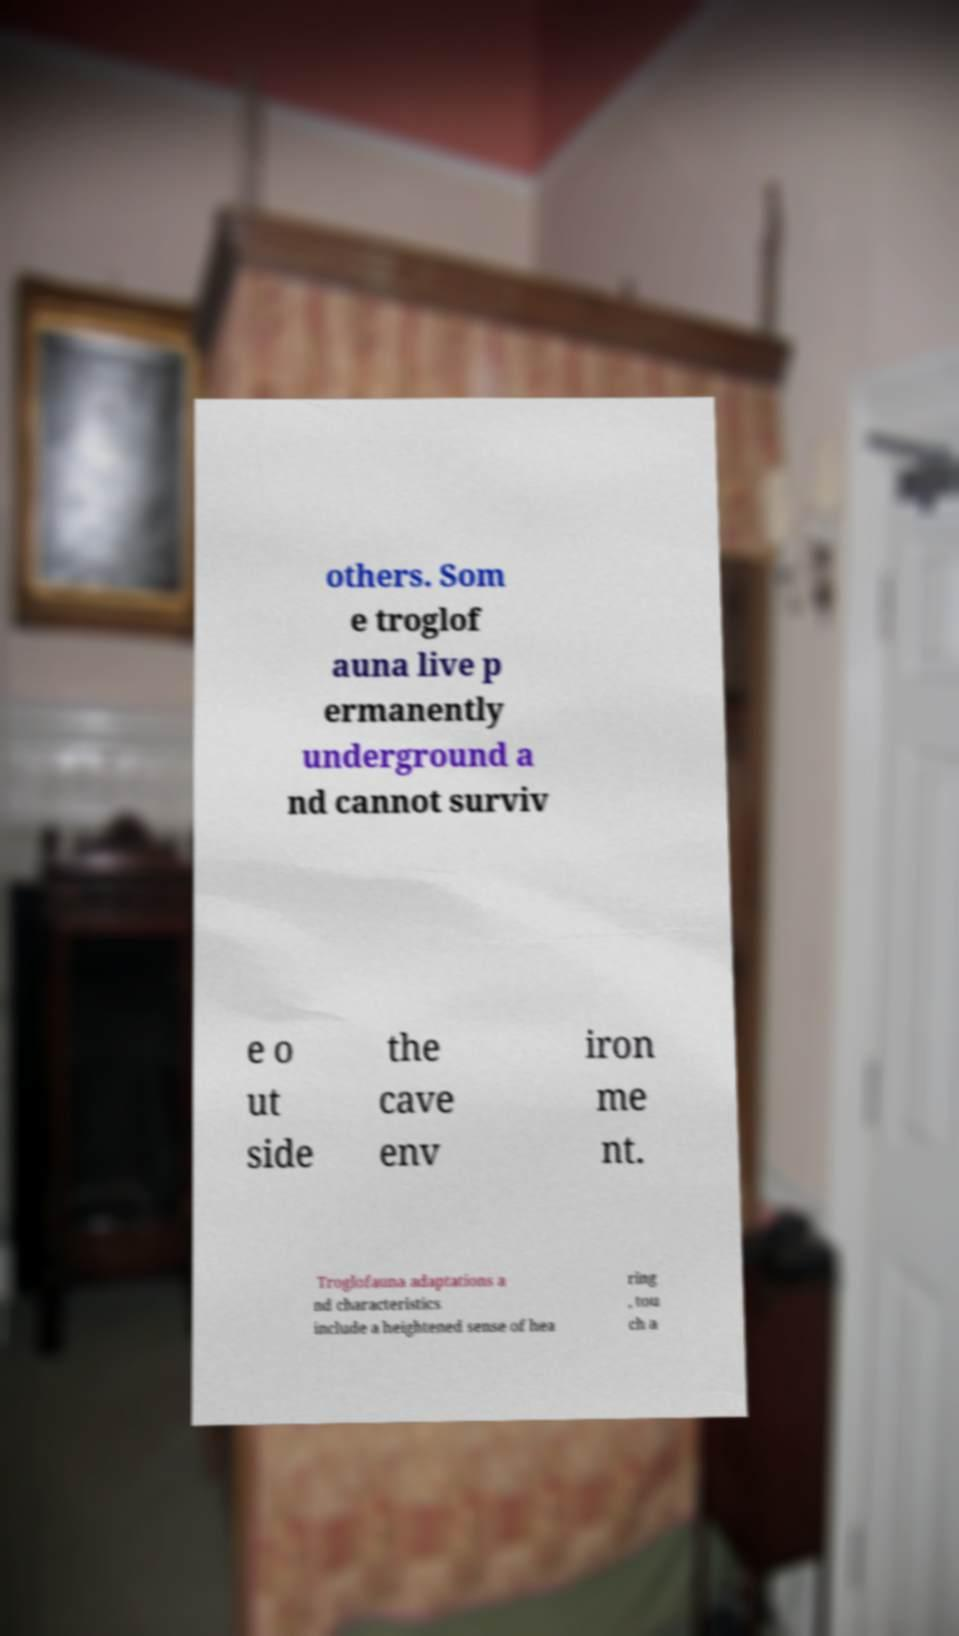Could you assist in decoding the text presented in this image and type it out clearly? others. Som e troglof auna live p ermanently underground a nd cannot surviv e o ut side the cave env iron me nt. Troglofauna adaptations a nd characteristics include a heightened sense of hea ring , tou ch a 